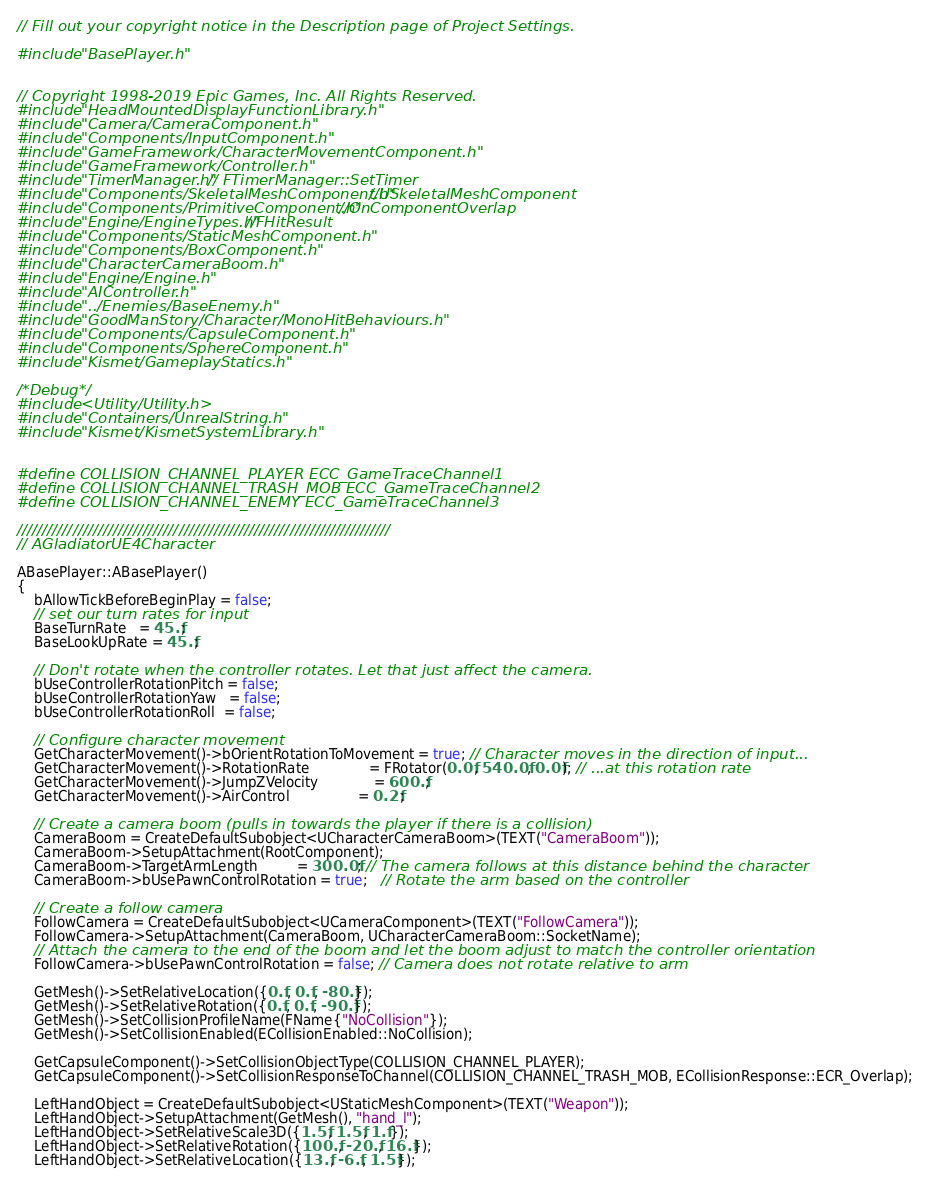Convert code to text. <code><loc_0><loc_0><loc_500><loc_500><_C++_>// Fill out your copyright notice in the Description page of Project Settings.

#include "BasePlayer.h"


// Copyright 1998-2019 Epic Games, Inc. All Rights Reserved.
#include "HeadMountedDisplayFunctionLibrary.h"
#include "Camera/CameraComponent.h"
#include "Components/InputComponent.h"
#include "GameFramework/CharacterMovementComponent.h"
#include "GameFramework/Controller.h"
#include "TimerManager.h" // FTimerManager::SetTimer
#include "Components/SkeletalMeshComponent.h" //USkeletalMeshComponent
#include "Components/PrimitiveComponent.h" //OnComponentOverlap
#include "Engine/EngineTypes.h" //FHitResult
#include "Components/StaticMeshComponent.h"
#include "Components/BoxComponent.h"
#include "CharacterCameraBoom.h"
#include "Engine/Engine.h"
#include "AIController.h"
#include "../Enemies/BaseEnemy.h"
#include "GoodManStory/Character/MonoHitBehaviours.h"
#include "Components/CapsuleComponent.h"
#include "Components/SphereComponent.h"
#include "Kismet/GameplayStatics.h"

/*Debug*/
#include <Utility/Utility.h>
#include "Containers/UnrealString.h"
#include "Kismet/KismetSystemLibrary.h"


#define COLLISION_CHANNEL_PLAYER ECC_GameTraceChannel1
#define COLLISION_CHANNEL_TRASH_MOB ECC_GameTraceChannel2
#define COLLISION_CHANNEL_ENEMY ECC_GameTraceChannel3

//////////////////////////////////////////////////////////////////////////
// AGladiatorUE4Character

ABasePlayer::ABasePlayer()
{
    bAllowTickBeforeBeginPlay = false;
    // set our turn rates for input
    BaseTurnRate   = 45.f;
    BaseLookUpRate = 45.f;

    // Don't rotate when the controller rotates. Let that just affect the camera.
    bUseControllerRotationPitch = false;
    bUseControllerRotationYaw   = false;
    bUseControllerRotationRoll  = false;

    // Configure character movement
    GetCharacterMovement()->bOrientRotationToMovement = true; // Character moves in the direction of input...	
    GetCharacterMovement()->RotationRate              = FRotator(0.0f, 540.0f, 0.0f); // ...at this rotation rate
    GetCharacterMovement()->JumpZVelocity             = 600.f;
    GetCharacterMovement()->AirControl                = 0.2f;

    // Create a camera boom (pulls in towards the player if there is a collision)
    CameraBoom = CreateDefaultSubobject<UCharacterCameraBoom>(TEXT("CameraBoom"));
    CameraBoom->SetupAttachment(RootComponent);
    CameraBoom->TargetArmLength         = 300.0f; // The camera follows at this distance behind the character	
    CameraBoom->bUsePawnControlRotation = true;   // Rotate the arm based on the controller

    // Create a follow camera
    FollowCamera = CreateDefaultSubobject<UCameraComponent>(TEXT("FollowCamera"));
    FollowCamera->SetupAttachment(CameraBoom, UCharacterCameraBoom::SocketName);
    // Attach the camera to the end of the boom and let the boom adjust to match the controller orientation
    FollowCamera->bUsePawnControlRotation = false; // Camera does not rotate relative to arm

    GetMesh()->SetRelativeLocation({0.f, 0.f, -80.f});
    GetMesh()->SetRelativeRotation({0.f, 0.f, -90.f});
    GetMesh()->SetCollisionProfileName(FName{"NoCollision"});
    GetMesh()->SetCollisionEnabled(ECollisionEnabled::NoCollision);

    GetCapsuleComponent()->SetCollisionObjectType(COLLISION_CHANNEL_PLAYER);
    GetCapsuleComponent()->SetCollisionResponseToChannel(COLLISION_CHANNEL_TRASH_MOB, ECollisionResponse::ECR_Overlap);

    LeftHandObject = CreateDefaultSubobject<UStaticMeshComponent>(TEXT("Weapon"));
    LeftHandObject->SetupAttachment(GetMesh(), "hand_l");
    LeftHandObject->SetRelativeScale3D({1.5f, 1.5f, 1.f});
    LeftHandObject->SetRelativeRotation({100.f, -20.f, 16.f});
    LeftHandObject->SetRelativeLocation({13.f, -6.f, 1.5f});</code> 